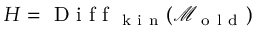<formula> <loc_0><loc_0><loc_500><loc_500>H = D i f f _ { k i n } ( \mathcal { M } _ { o l d } )</formula> 